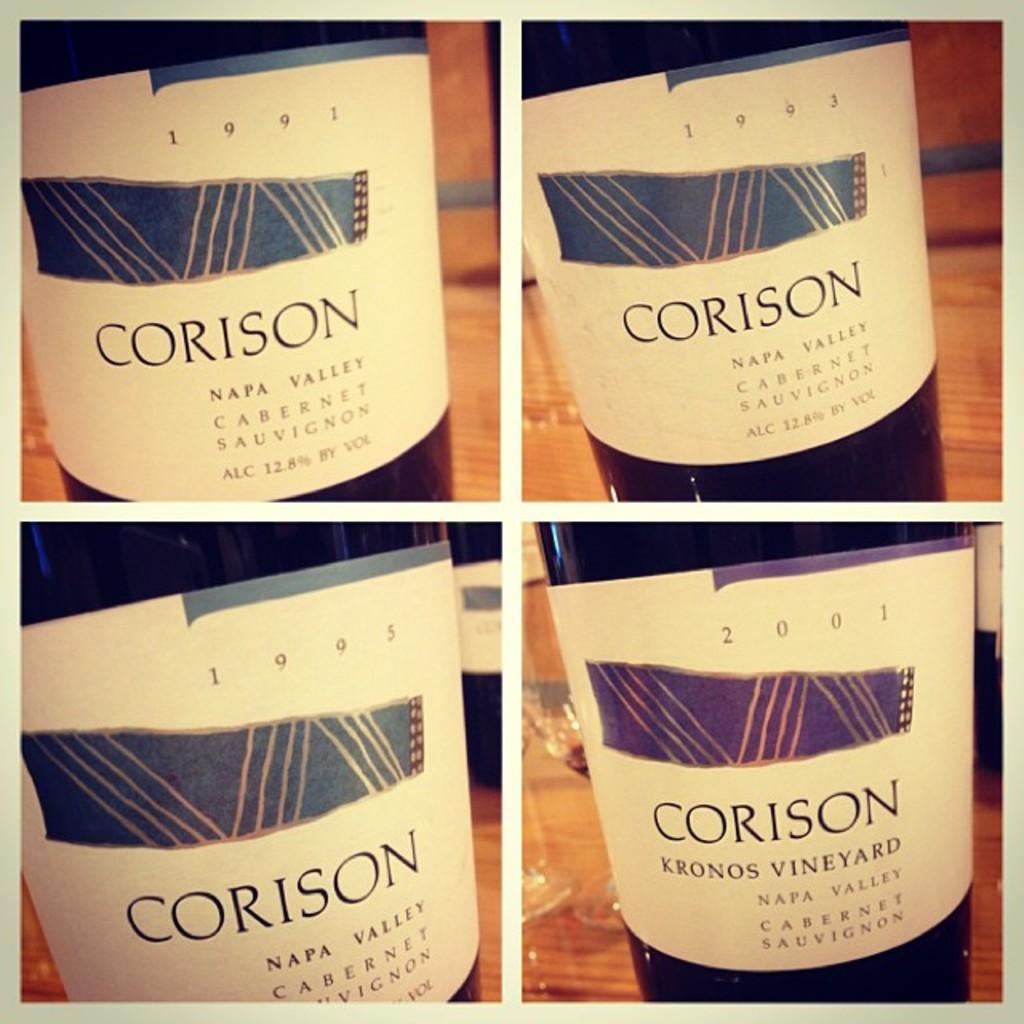<image>
Share a concise interpretation of the image provided. Corison's cabernet sauvignon has a label with lines and the color purple and blue. 